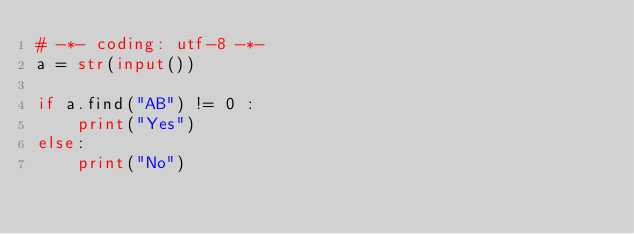<code> <loc_0><loc_0><loc_500><loc_500><_Python_># -*- coding: utf-8 -*-
a = str(input())

if a.find("AB") != 0 :
	print("Yes")
else:
	print("No")
</code> 